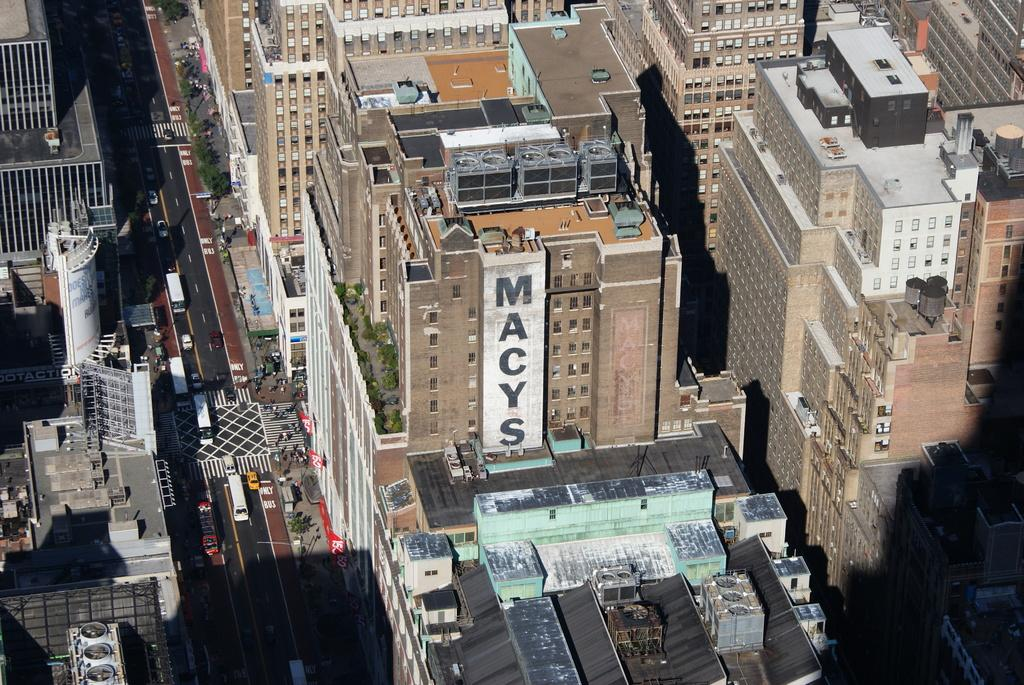What type of structures can be seen in the image? There are buildings in the image. What is the purpose of the road in the image? The road in the image is used for vehicles to travel on. What types of vehicles are visible in the image? There are vehicles in the image. What type of vegetation can be seen in the image? There are trees in the image. What letter is written on the side of the trees in the image? There are no letters written on the trees in the image; they are simply trees. What type of shock can be seen in the image? There is no shock present in the image; it features buildings, a road, vehicles, and trees. 